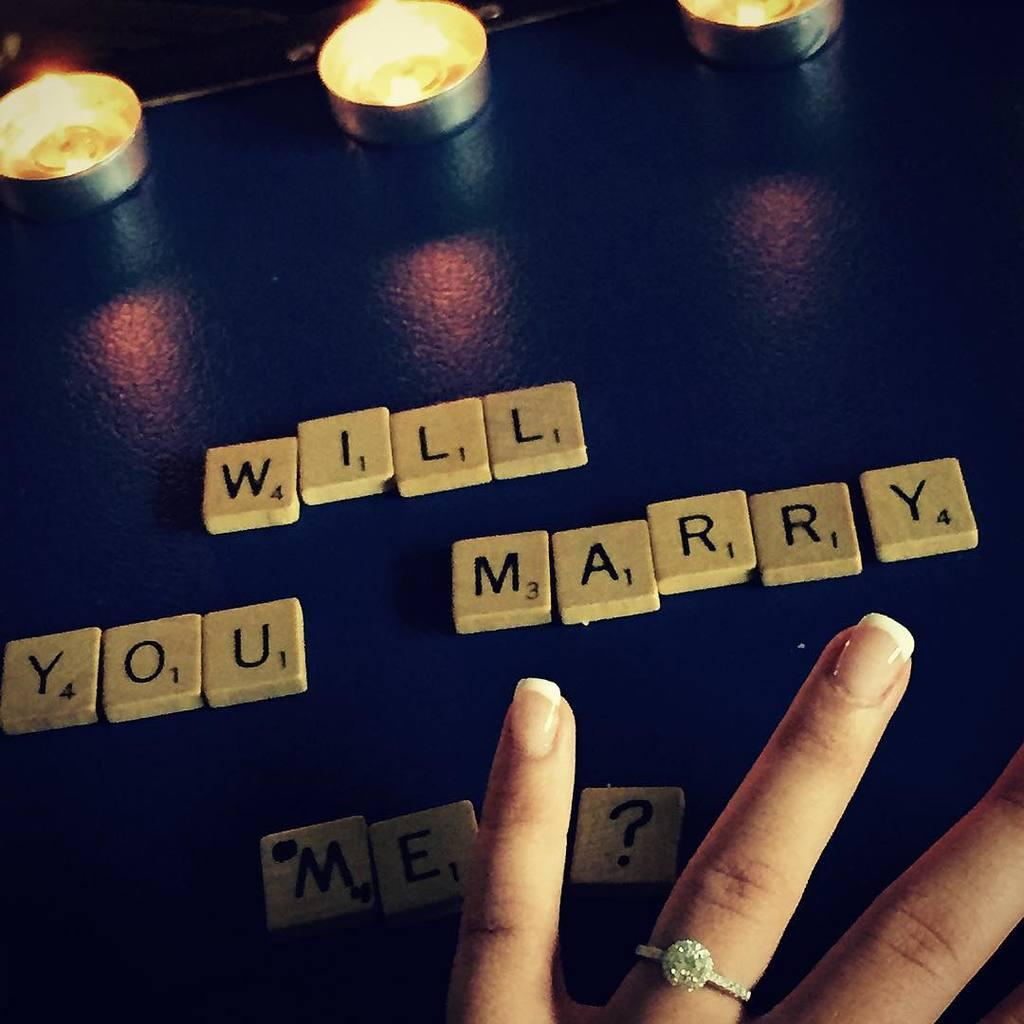What objects can be seen in the image related to lighting? There are candles in the image. What type of educational toy is present in the image? There are alphabet blocks in the image. Whose hand is visible in the image? A human hand is visible in the image. On what surface are the candles and alphabet blocks placed? The candles and alphabet blocks are on a surface. What type of card is being woven with thread in the image? There is no card or thread present in the image. How many straws are being used to create a structure in the image? There are no straws present in the image. 